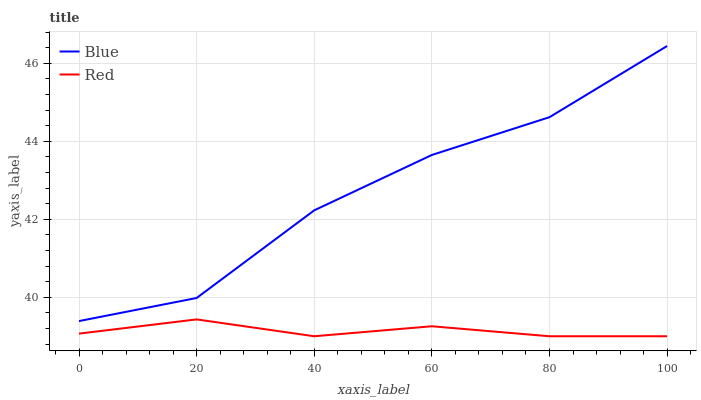Does Red have the minimum area under the curve?
Answer yes or no. Yes. Does Blue have the maximum area under the curve?
Answer yes or no. Yes. Does Red have the maximum area under the curve?
Answer yes or no. No. Is Red the smoothest?
Answer yes or no. Yes. Is Blue the roughest?
Answer yes or no. Yes. Is Red the roughest?
Answer yes or no. No. Does Blue have the highest value?
Answer yes or no. Yes. Does Red have the highest value?
Answer yes or no. No. Is Red less than Blue?
Answer yes or no. Yes. Is Blue greater than Red?
Answer yes or no. Yes. Does Red intersect Blue?
Answer yes or no. No. 